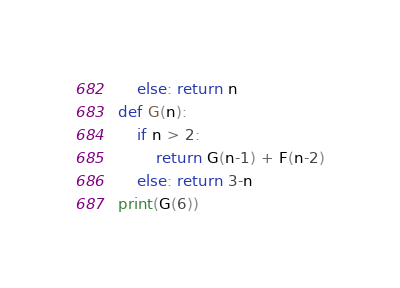<code> <loc_0><loc_0><loc_500><loc_500><_Python_>    else: return n
def G(n):
    if n > 2:
        return G(n-1) + F(n-2)
    else: return 3-n
print(G(6))</code> 